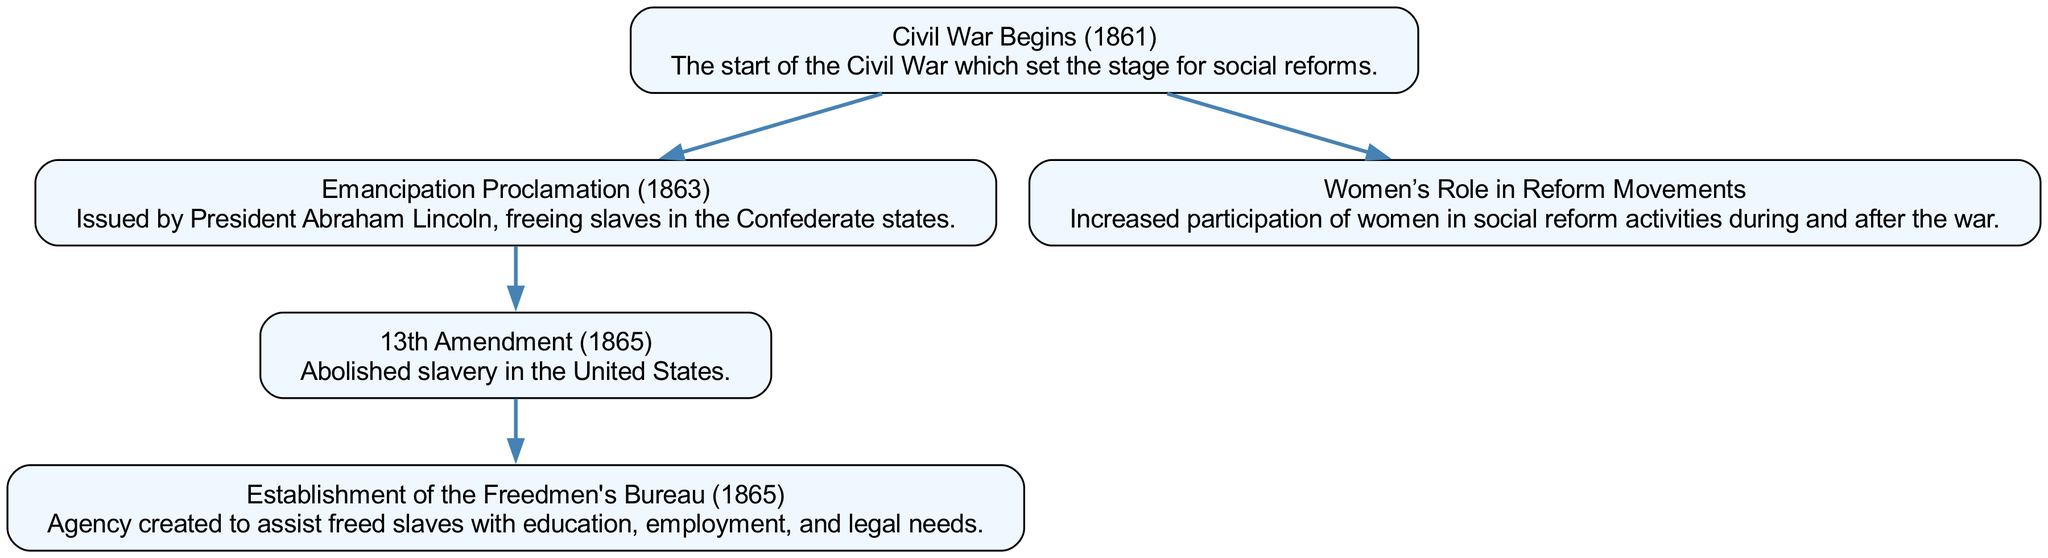What event marks the beginning of social reforms during the Civil War? The diagram shows "Civil War Begins (1861)" as the starting node leading to various reforms, indicating that this event initiated the subsequent reforms.
Answer: Civil War Begins (1861) How many social reform events are represented in the diagram? By counting the nodes in the diagram, we see five distinct social reform events listed, each marked by a unique node.
Answer: 5 Which amendment abolished slavery in the United States? The diagram includes the node labeled "13th Amendment (1865)", which explicitly states that it abolished slavery, connecting to the previous events.
Answer: 13th Amendment (1865) What agency was established to assist freed slaves? The diagram shows the node "Establishment of the Freedmen's Bureau (1865)", indicating its role in supporting freed slaves, following the 13th Amendment.
Answer: Establishment of the Freedmen's Bureau (1865) What was the connection between the Emancipation Proclamation and the Freedmen's Bureau? From the diagram flow, the Emancipation Proclamation leads directly to the 13th Amendment, which in turn leads to the Freedmen's Bureau, indicating a progression from freeing slaves to establishing support for them.
Answer: Emancipation Proclamation to 13th Amendment to Freedmen's Bureau How did the Civil War influence women's participation in reform movements? The diagram has a direct edge from "Civil War Begins (1861)" to "Women’s Role in Reform Movements", indicating that the war created an environment that encouraged women's involvement in social reforms.
Answer: Increased participation of women in social reform activities Which event immediately preceded the establishment of the Freedmen's Bureau? The edge connecting the "13th Amendment" to the "Freedmen's Bureau" in the diagram shows that the establishment of the Freedmen's Bureau followed the ratification of the 13th Amendment.
Answer: 13th Amendment How many edges are connecting the nodes in the diagram? By counting the connections (edges) displayed in the diagram, we find four edges linking the different events, which show the direction of influence among them.
Answer: 4 